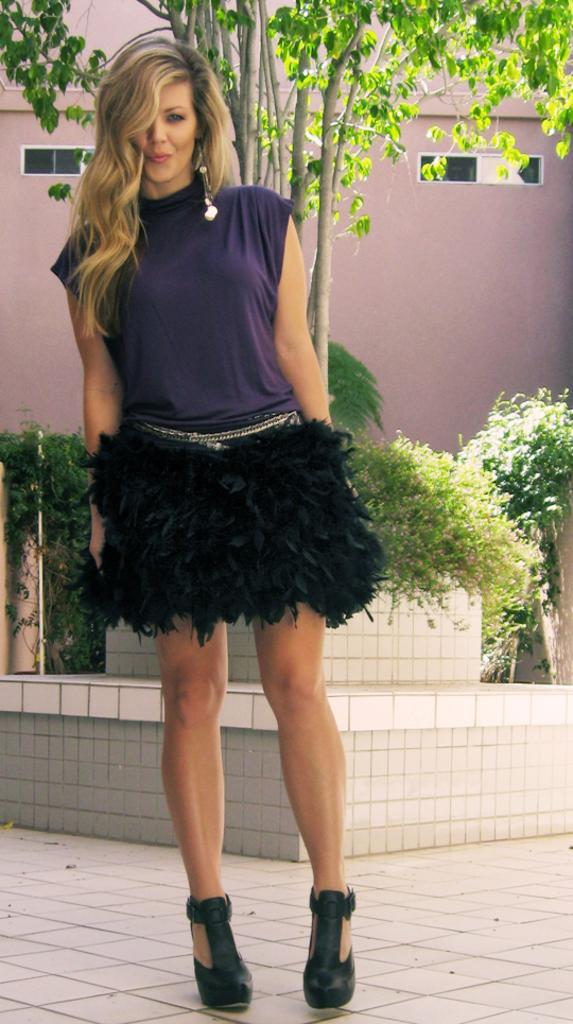What is the main subject in the image? There is a woman standing in the image. What can be seen behind the woman? There are plants and trees behind the woman. What type of structure is visible in the image? There is a building visible in the image. What type of net is being used by the woman in the image? There is no net present in the image; the woman is simply standing. 